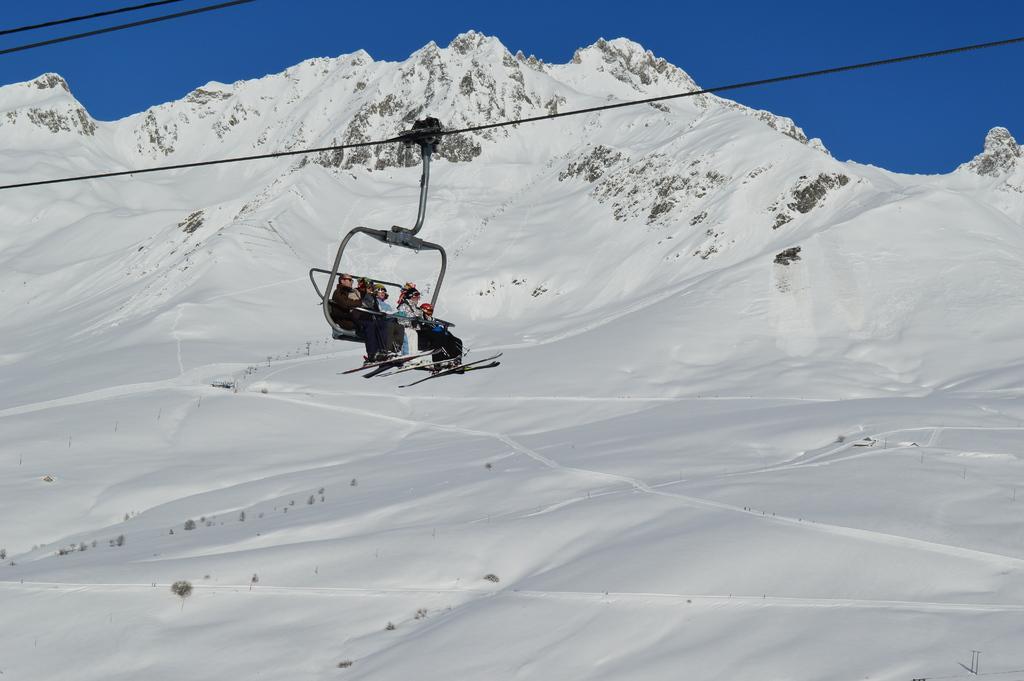How would you summarize this image in a sentence or two? In this image, we can see some persons in the Ropeway ride. There is a sky at the top of the image. There is a mountain in the middle of the image. 